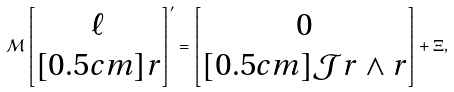<formula> <loc_0><loc_0><loc_500><loc_500>\mathcal { M } \begin{bmatrix} \ell \\ [ 0 . 5 c m ] r \end{bmatrix} ^ { \prime } = \begin{bmatrix} 0 \\ [ 0 . 5 c m ] \mathcal { J } r \wedge r \end{bmatrix} + \Xi ,</formula> 